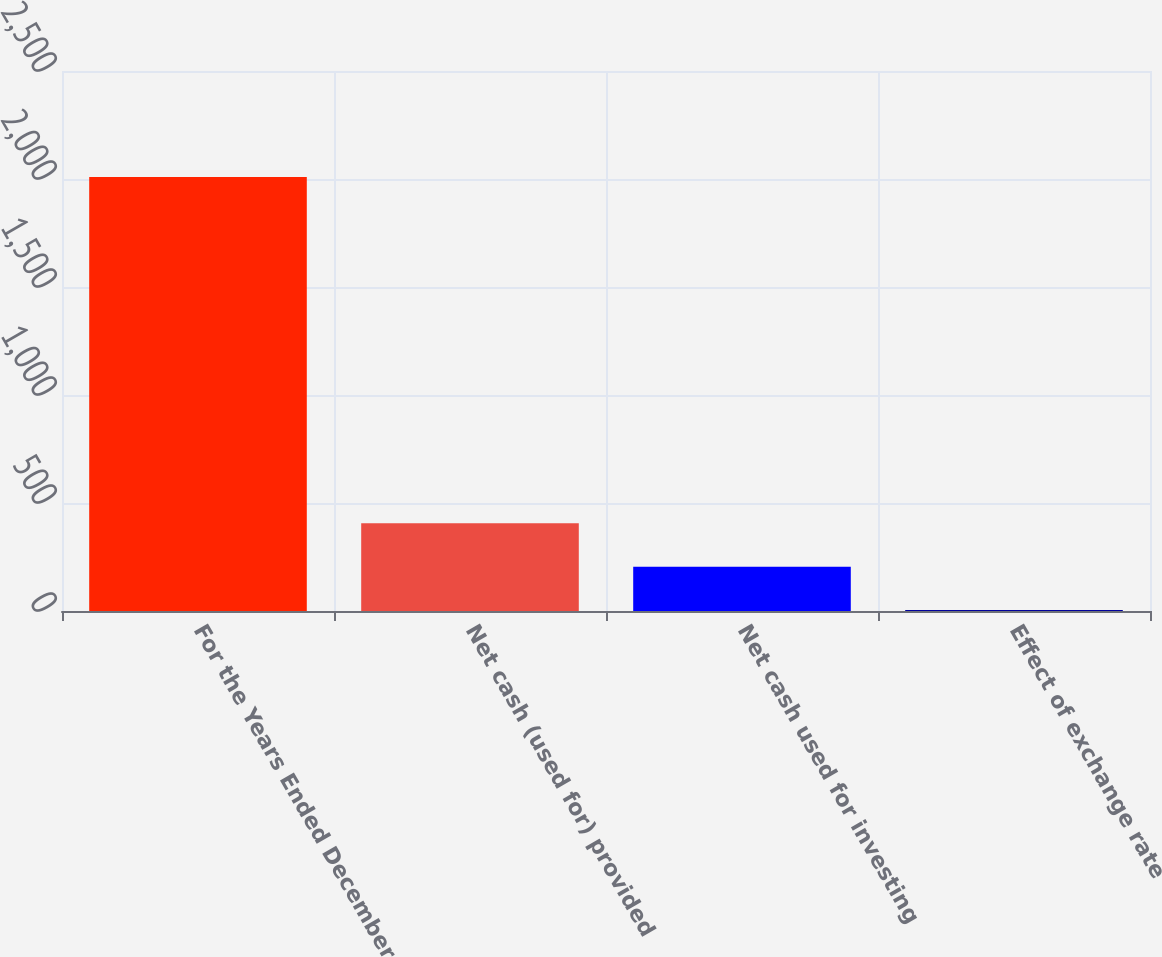Convert chart. <chart><loc_0><loc_0><loc_500><loc_500><bar_chart><fcel>For the Years Ended December<fcel>Net cash (used for) provided<fcel>Net cash used for investing<fcel>Effect of exchange rate<nl><fcel>2009<fcel>405.8<fcel>205.4<fcel>5<nl></chart> 